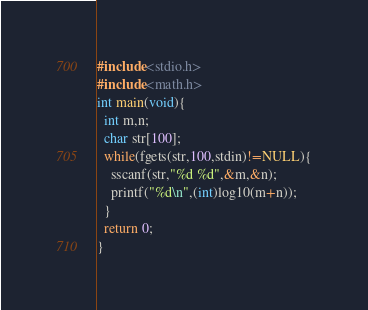<code> <loc_0><loc_0><loc_500><loc_500><_C_>#include<stdio.h>
#include<math.h>
int main(void){
  int m,n;
  char str[100];
  while(fgets(str,100,stdin)!=NULL){
    sscanf(str,"%d %d",&m,&n);
    printf("%d\n",(int)log10(m+n));
  }
  return 0;
}</code> 